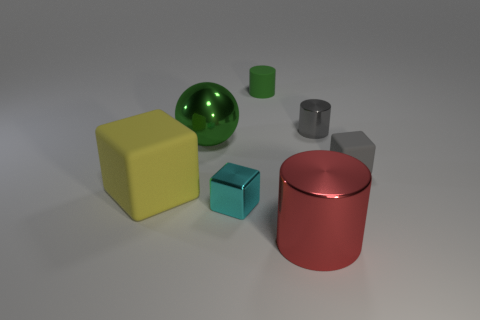There is a sphere that is the same color as the matte cylinder; what is its size?
Offer a terse response. Large. Is there a object of the same color as the big metallic sphere?
Make the answer very short. Yes. There is a rubber block that is the same size as the gray metallic thing; what is its color?
Your answer should be very brief. Gray. There is a rubber object behind the small gray block; are there any small green matte cylinders left of it?
Your answer should be compact. No. There is a tiny gray object left of the gray block; what is its material?
Your answer should be very brief. Metal. Does the small cylinder that is to the right of the tiny green matte thing have the same material as the green object that is on the right side of the cyan metallic object?
Provide a short and direct response. No. Are there the same number of green matte cylinders to the right of the tiny green matte thing and green metal balls that are behind the tiny metallic cube?
Your answer should be very brief. No. How many small green cylinders have the same material as the big yellow thing?
Offer a very short reply. 1. There is a thing that is the same color as the matte cylinder; what is its shape?
Make the answer very short. Sphere. How big is the yellow matte object in front of the large metallic object that is behind the yellow object?
Provide a succinct answer. Large. 